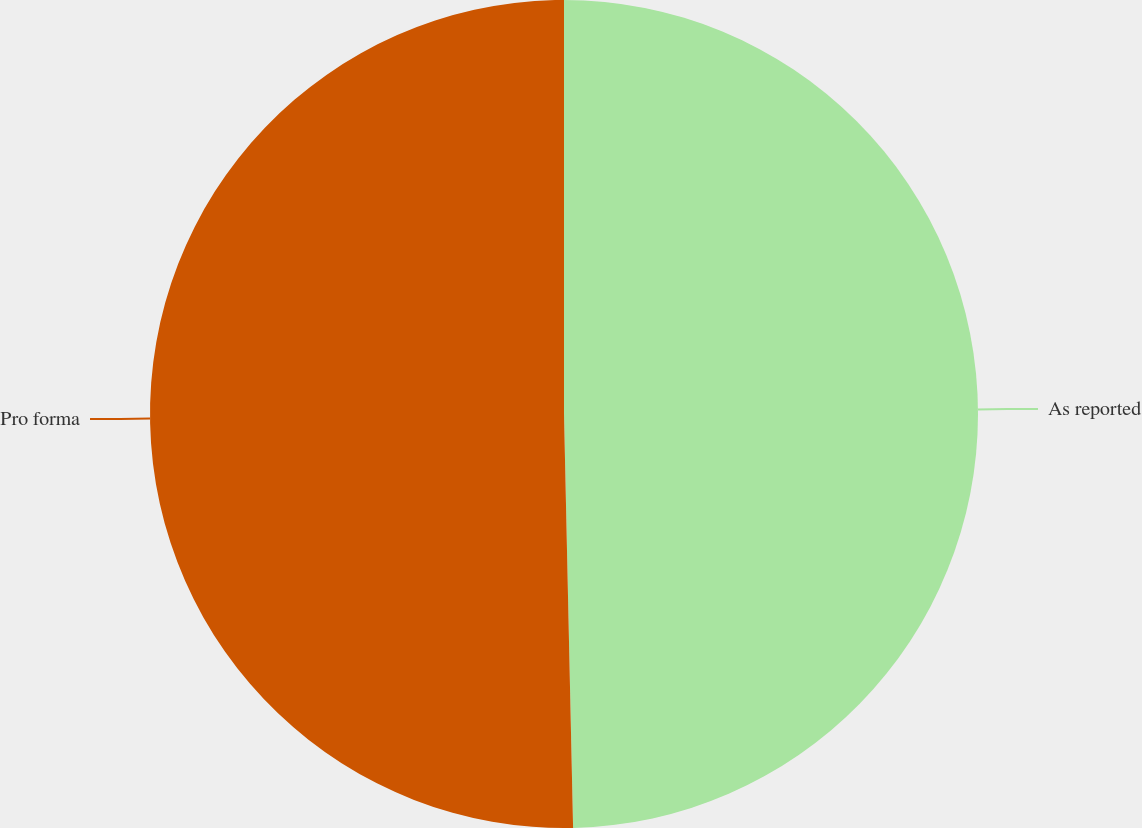Convert chart to OTSL. <chart><loc_0><loc_0><loc_500><loc_500><pie_chart><fcel>As reported<fcel>Pro forma<nl><fcel>49.65%<fcel>50.35%<nl></chart> 